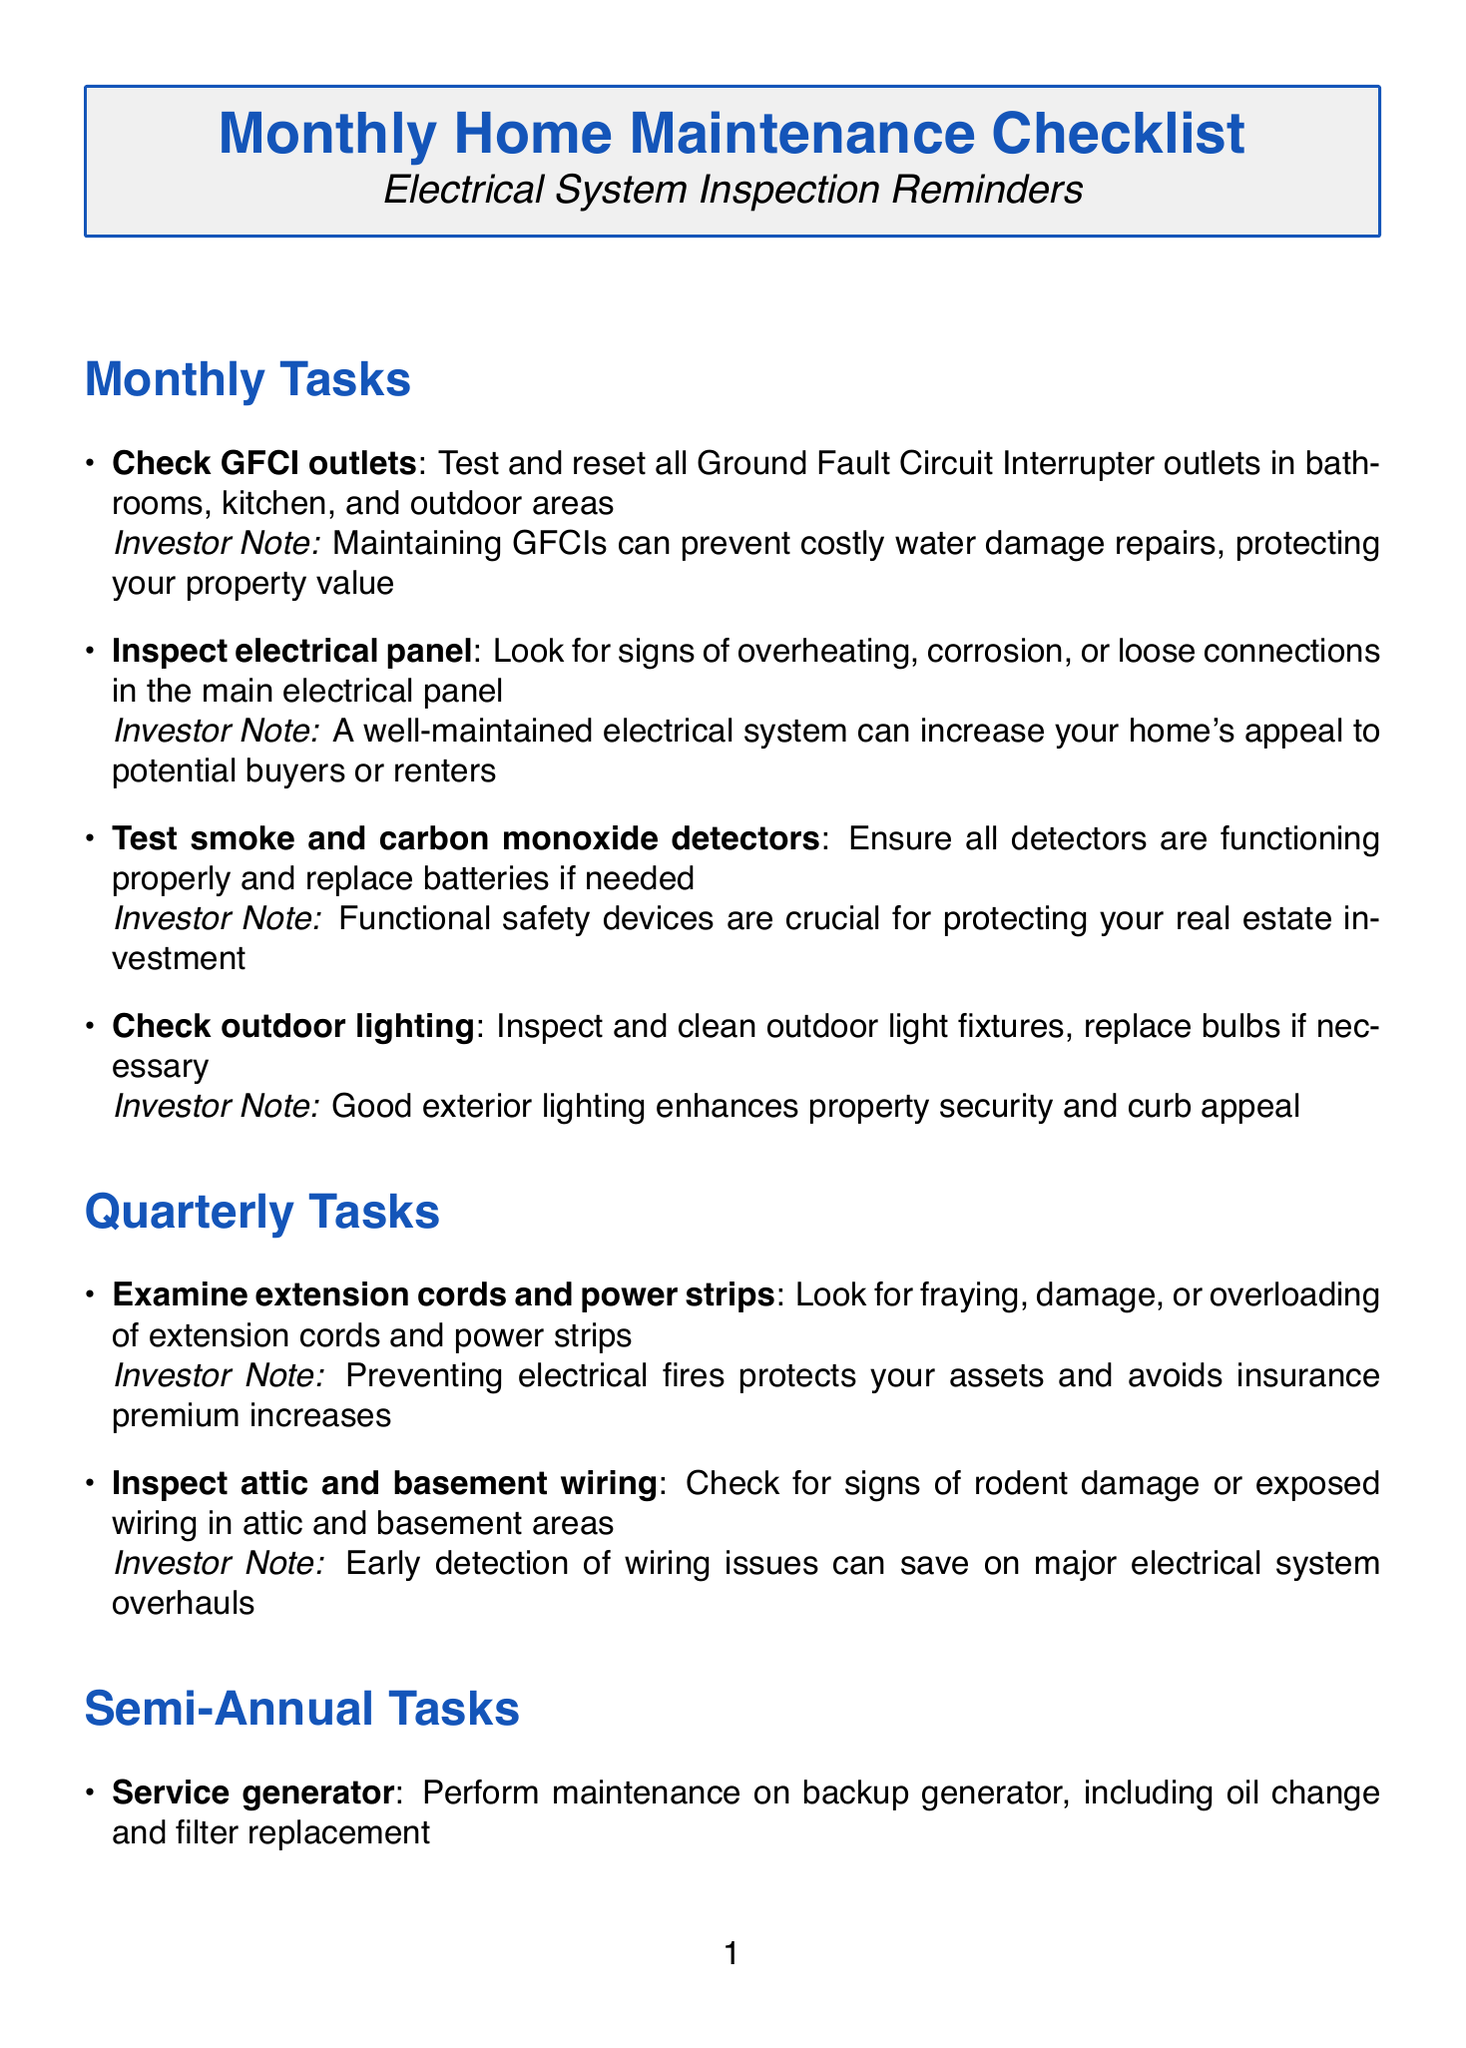What is the first monthly task? The first monthly task listed in the document is to check GFCI outlets.
Answer: Check GFCI outlets How many semi-annual tasks are there? The document lists two tasks under the semi-annual category.
Answer: 2 What location is specified for the fire extinguisher? The fire extinguisher should be located in the kitchen, garage, and near the electrical panel.
Answer: Kitchen, garage, and near electrical panel What is the investor note for testing smoke detectors? The investor note emphasizes that functional safety devices are crucial for protecting your real estate investment.
Answer: Functional safety devices are crucial for protecting your real estate investment Which service is provided by HomeShield Insurance? HomeShield Insurance provides home insurance for claims and policy updates.
Answer: Home insurance provider for claims and policy updates What type of maintenance is required for voltage testers? The maintenance required is to test on a known live circuit before each use and replace batteries annually.
Answer: Test on known live circuit before each use, replace batteries annually 